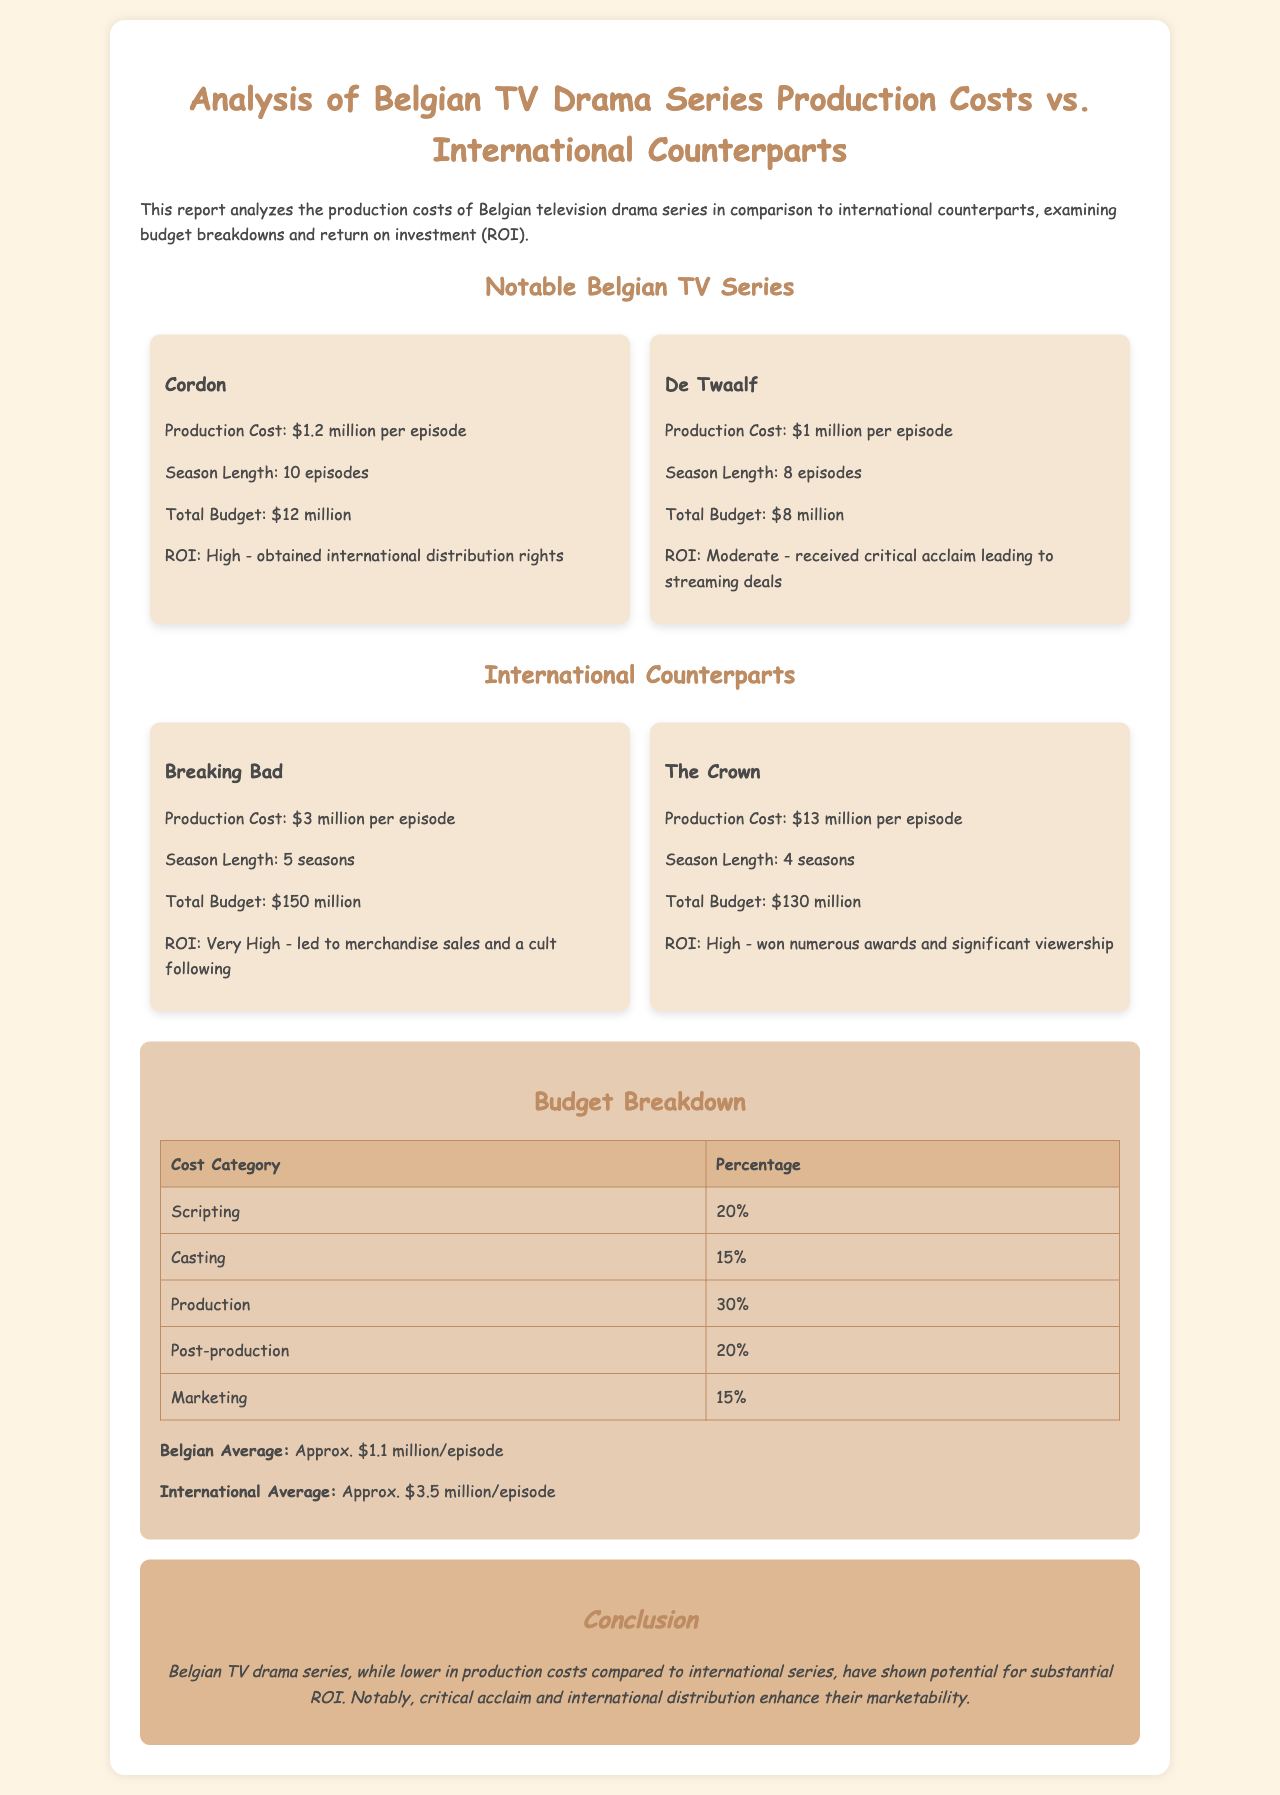what is the production cost of Cordon? The production cost of Cordon is stated in the document as $1.2 million per episode.
Answer: $1.2 million per episode how many episodes are in De Twaalf? The document specifies that De Twaalf has 8 episodes in total.
Answer: 8 episodes what is the ROI for The Crown? The ROI for The Crown is described as High in the document due to its numerous awards and significant viewership.
Answer: High what is the total budget for Breaking Bad? The total budget for Breaking Bad is mentioned as $150 million.
Answer: $150 million what percentage of the budget is allocated to production? The document indicates that 30% of the budget is allocated to production.
Answer: 30% which Belgian series has a moderate ROI? De Twaalf is noted for having a moderate ROI based on critical acclaim and streaming deals.
Answer: De Twaalf what is the average production cost for Belgian TV drama series? The document provides that the Belgian average production cost is approximately $1.1 million per episode.
Answer: Approx. $1.1 million/episode how does the average production cost of international series compare? The international average production cost is stated to be approximately $3.5 million per episode.
Answer: Approx. $3.5 million/episode 